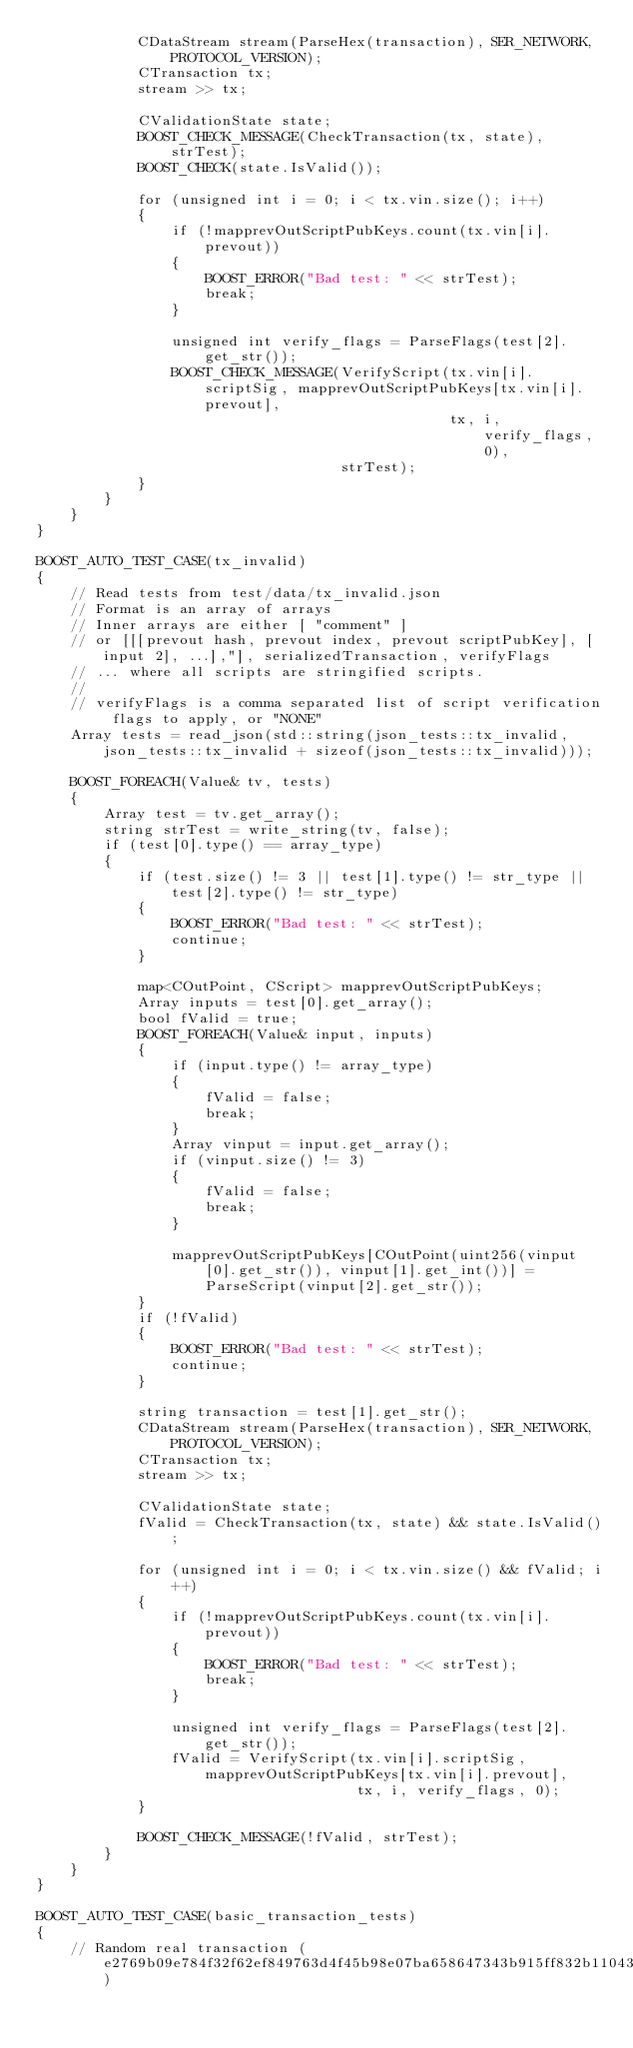<code> <loc_0><loc_0><loc_500><loc_500><_C++_>            CDataStream stream(ParseHex(transaction), SER_NETWORK, PROTOCOL_VERSION);
            CTransaction tx;
            stream >> tx;

            CValidationState state;
            BOOST_CHECK_MESSAGE(CheckTransaction(tx, state), strTest);
            BOOST_CHECK(state.IsValid());

            for (unsigned int i = 0; i < tx.vin.size(); i++)
            {
                if (!mapprevOutScriptPubKeys.count(tx.vin[i].prevout))
                {
                    BOOST_ERROR("Bad test: " << strTest);
                    break;
                }

                unsigned int verify_flags = ParseFlags(test[2].get_str());
                BOOST_CHECK_MESSAGE(VerifyScript(tx.vin[i].scriptSig, mapprevOutScriptPubKeys[tx.vin[i].prevout],
                                                 tx, i, verify_flags, 0),
                                    strTest);
            }
        }
    }
}

BOOST_AUTO_TEST_CASE(tx_invalid)
{
    // Read tests from test/data/tx_invalid.json
    // Format is an array of arrays
    // Inner arrays are either [ "comment" ]
    // or [[[prevout hash, prevout index, prevout scriptPubKey], [input 2], ...],"], serializedTransaction, verifyFlags
    // ... where all scripts are stringified scripts.
    //
    // verifyFlags is a comma separated list of script verification flags to apply, or "NONE"
    Array tests = read_json(std::string(json_tests::tx_invalid, json_tests::tx_invalid + sizeof(json_tests::tx_invalid)));

    BOOST_FOREACH(Value& tv, tests)
    {
        Array test = tv.get_array();
        string strTest = write_string(tv, false);
        if (test[0].type() == array_type)
        {
            if (test.size() != 3 || test[1].type() != str_type || test[2].type() != str_type)
            {
                BOOST_ERROR("Bad test: " << strTest);
                continue;
            }

            map<COutPoint, CScript> mapprevOutScriptPubKeys;
            Array inputs = test[0].get_array();
            bool fValid = true;
            BOOST_FOREACH(Value& input, inputs)
            {
                if (input.type() != array_type)
                {
                    fValid = false;
                    break;
                }
                Array vinput = input.get_array();
                if (vinput.size() != 3)
                {
                    fValid = false;
                    break;
                }

                mapprevOutScriptPubKeys[COutPoint(uint256(vinput[0].get_str()), vinput[1].get_int())] = ParseScript(vinput[2].get_str());
            }
            if (!fValid)
            {
                BOOST_ERROR("Bad test: " << strTest);
                continue;
            }

            string transaction = test[1].get_str();
            CDataStream stream(ParseHex(transaction), SER_NETWORK, PROTOCOL_VERSION);
            CTransaction tx;
            stream >> tx;

            CValidationState state;
            fValid = CheckTransaction(tx, state) && state.IsValid();

            for (unsigned int i = 0; i < tx.vin.size() && fValid; i++)
            {
                if (!mapprevOutScriptPubKeys.count(tx.vin[i].prevout))
                {
                    BOOST_ERROR("Bad test: " << strTest);
                    break;
                }

                unsigned int verify_flags = ParseFlags(test[2].get_str());
                fValid = VerifyScript(tx.vin[i].scriptSig, mapprevOutScriptPubKeys[tx.vin[i].prevout],
                                      tx, i, verify_flags, 0);
            }

            BOOST_CHECK_MESSAGE(!fValid, strTest);
        }
    }
}

BOOST_AUTO_TEST_CASE(basic_transaction_tests)
{
    // Random real transaction (e2769b09e784f32f62ef849763d4f45b98e07ba658647343b915ff832b110436)</code> 